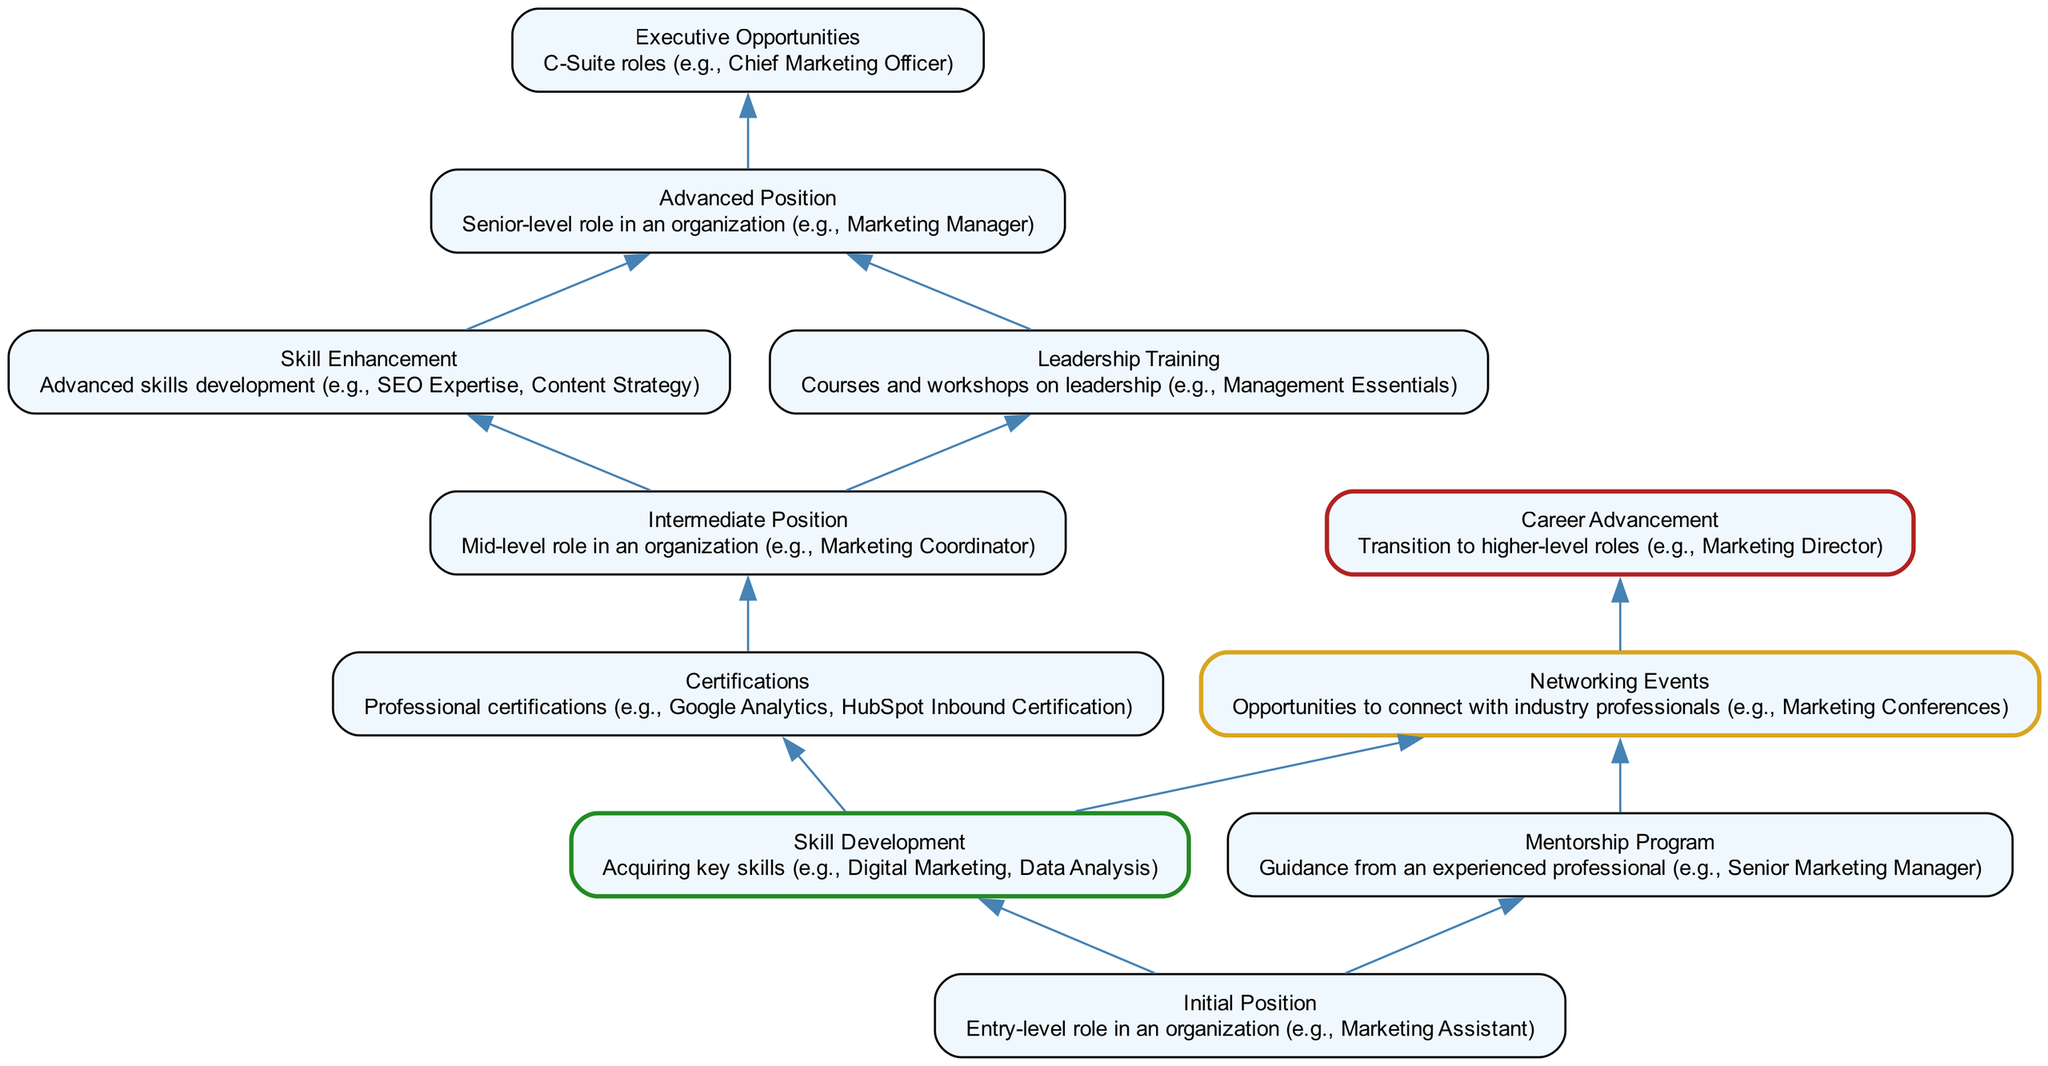What is the initial position in the diagram? The diagram explicitly states that the initial position represents an "Entry-level role in an organization (e.g., Marketing Assistant)." Therefore, by looking at the descriptive information associated with the "Initial Position" node, we can conclude the answer.
Answer: Entry-level role in an organization (e.g., Marketing Assistant) How many connections does the "Skill Development" node have? The "Skill Development" node has two distinct connections as shown in the diagram: "Certifications" and "Networking Events." Counting these connections gives us the answer.
Answer: 2 What is the final node in the flow? The last node in the flow is "Career Advancement," as it is not connected to any other nodes, indicating that it is the end of the pathway in the diagram. No further connections exist beyond this node.
Answer: Career Advancement Which skills are acquired in the "Skill Enhancement" stage? The "Skill Enhancement" node explains that advanced skills such as "SEO Expertise" and "Content Strategy" are developed at this stage. Referencing the description connected to this specific node provides clarity on the skills involved.
Answer: SEO Expertise, Content Strategy If someone completes "Certifications," what is their next stage? Upon completing "Certifications," the next stage indicated in the diagram is the "Intermediate Position." This connection shows a clear pathway from one node to another as represented in the flowchart.
Answer: Intermediate Position What type of opportunities does "Executive Opportunities" refer to? The description connected to the "Executive Opportunities" node refers specifically to "C-Suite roles (e.g., Chief Marketing Officer)." This indicates that the opportunities highlighted here are at the highest organizational level.
Answer: C-Suite roles (e.g., Chief Marketing Officer) What is one way to transition from the "Initial Position" to the "Intermediate Position"? One pathway from the "Initial Position" to the "Intermediate Position" is through completing "Skill Development," which connects directly to further opportunities leading to positions of higher responsibility.
Answer: Skill Development How does "Networking Events" contribute to "Career Advancement"? "Networking Events" provides opportunities to connect with industry professionals, which then leads to "Career Advancement." The step is outlined in the flowchart, indicating the influence of networking.
Answer: Opportunities to connect with industry professionals What role is indicated by the "Advanced Position"? The "Advanced Position" node corresponds to roles such as "Senior-level role in an organization (e.g., Marketing Manager)," representing a higher level of responsibility and experience. Looking at the description informs this answer.
Answer: Senior-level role in an organization (e.g., Marketing Manager) 